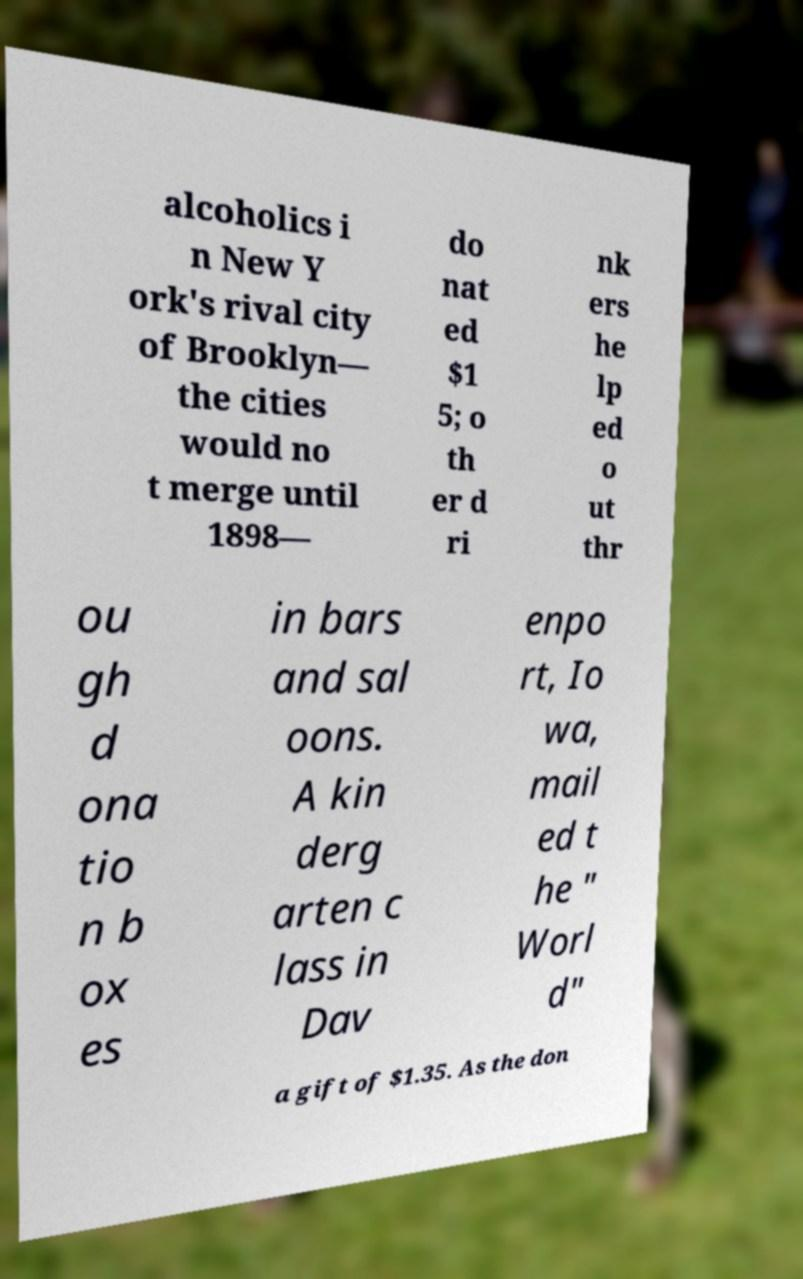What messages or text are displayed in this image? I need them in a readable, typed format. alcoholics i n New Y ork's rival city of Brooklyn— the cities would no t merge until 1898— do nat ed $1 5; o th er d ri nk ers he lp ed o ut thr ou gh d ona tio n b ox es in bars and sal oons. A kin derg arten c lass in Dav enpo rt, Io wa, mail ed t he " Worl d" a gift of $1.35. As the don 